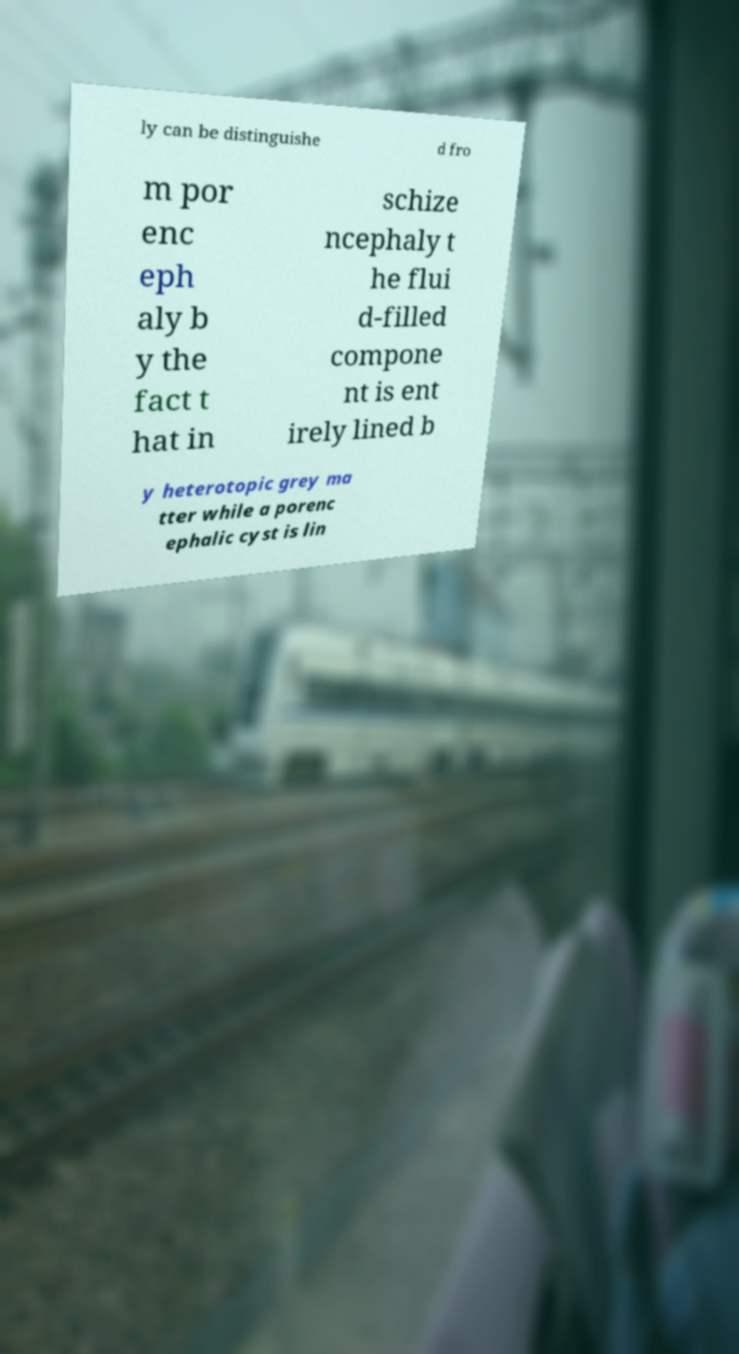Could you extract and type out the text from this image? ly can be distinguishe d fro m por enc eph aly b y the fact t hat in schize ncephaly t he flui d-filled compone nt is ent irely lined b y heterotopic grey ma tter while a porenc ephalic cyst is lin 